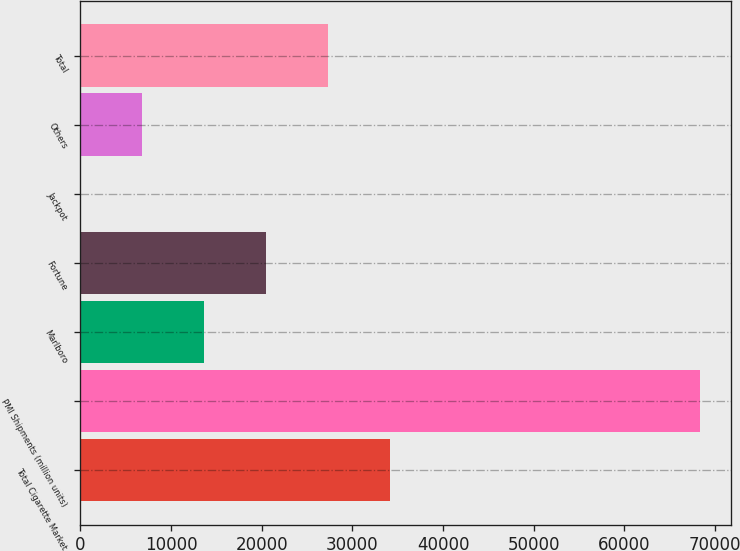Convert chart to OTSL. <chart><loc_0><loc_0><loc_500><loc_500><bar_chart><fcel>Total Cigarette Market<fcel>PMI Shipments (million units)<fcel>Marlboro<fcel>Fortune<fcel>Jackpot<fcel>Others<fcel>Total<nl><fcel>34184.3<fcel>68358<fcel>13680.2<fcel>20514.9<fcel>10.7<fcel>6845.43<fcel>27349.6<nl></chart> 